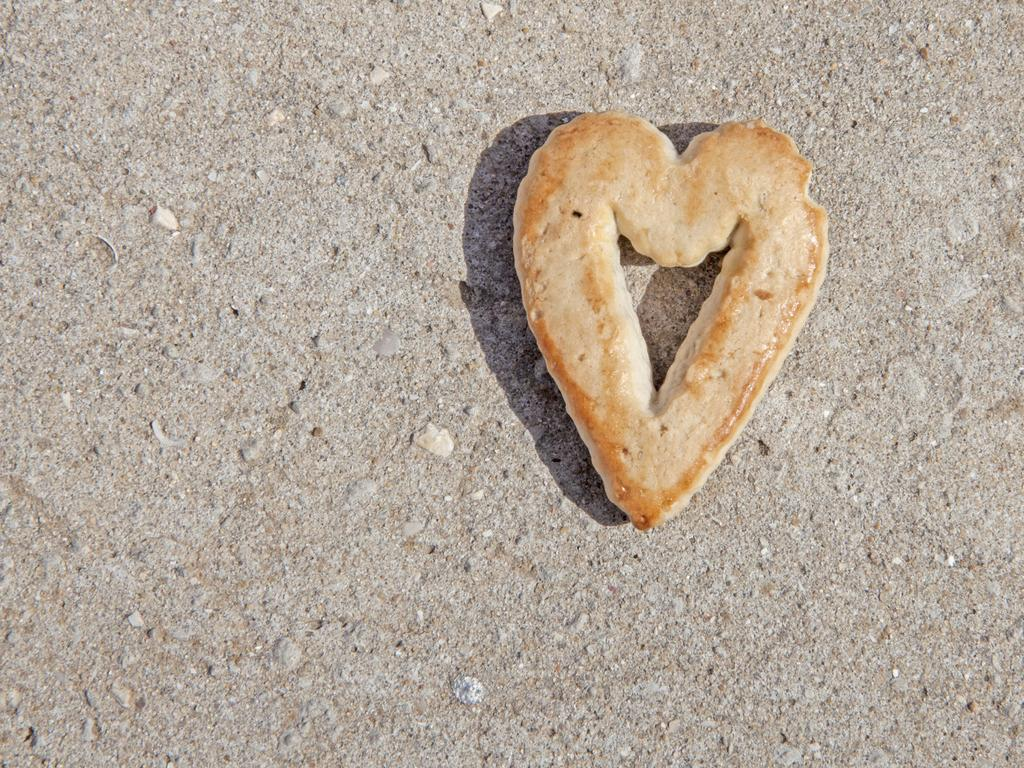What can be seen in the image that people might walk on? There is a path visible in the image that people might walk on. What type of food item is present in the image? There is a food item in the shape of a heart in the image. What disease is being treated by the heart-shaped food item in the image? There is no disease mentioned or depicted in the image, and the heart-shaped food item is not associated with any medical treatment. 